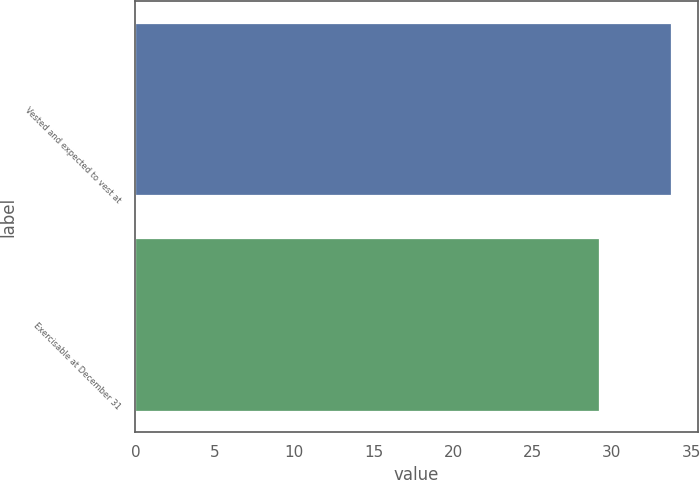<chart> <loc_0><loc_0><loc_500><loc_500><bar_chart><fcel>Vested and expected to vest at<fcel>Exercisable at December 31<nl><fcel>33.71<fcel>29.16<nl></chart> 